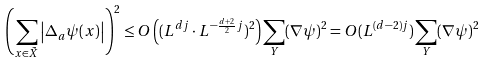Convert formula to latex. <formula><loc_0><loc_0><loc_500><loc_500>\left ( \sum _ { x \in \tilde { X } } \left | \Delta _ { a } \psi ( x ) \right | \right ) ^ { 2 } \leq O \left ( ( L ^ { d j } \cdot L ^ { - \frac { d + 2 } { 2 } j } ) ^ { 2 } \right ) \sum _ { Y } ( \nabla \psi ) ^ { 2 } = O ( L ^ { ( d - 2 ) j } ) \sum _ { Y } ( \nabla \psi ) ^ { 2 }</formula> 